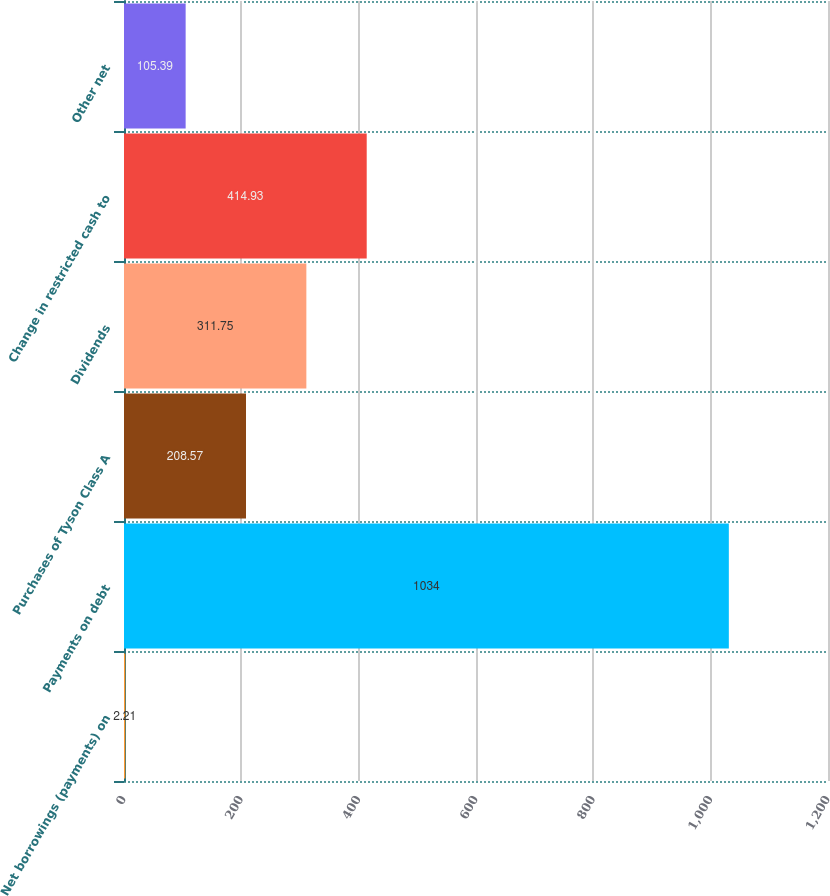Convert chart. <chart><loc_0><loc_0><loc_500><loc_500><bar_chart><fcel>Net borrowings (payments) on<fcel>Payments on debt<fcel>Purchases of Tyson Class A<fcel>Dividends<fcel>Change in restricted cash to<fcel>Other net<nl><fcel>2.21<fcel>1034<fcel>208.57<fcel>311.75<fcel>414.93<fcel>105.39<nl></chart> 